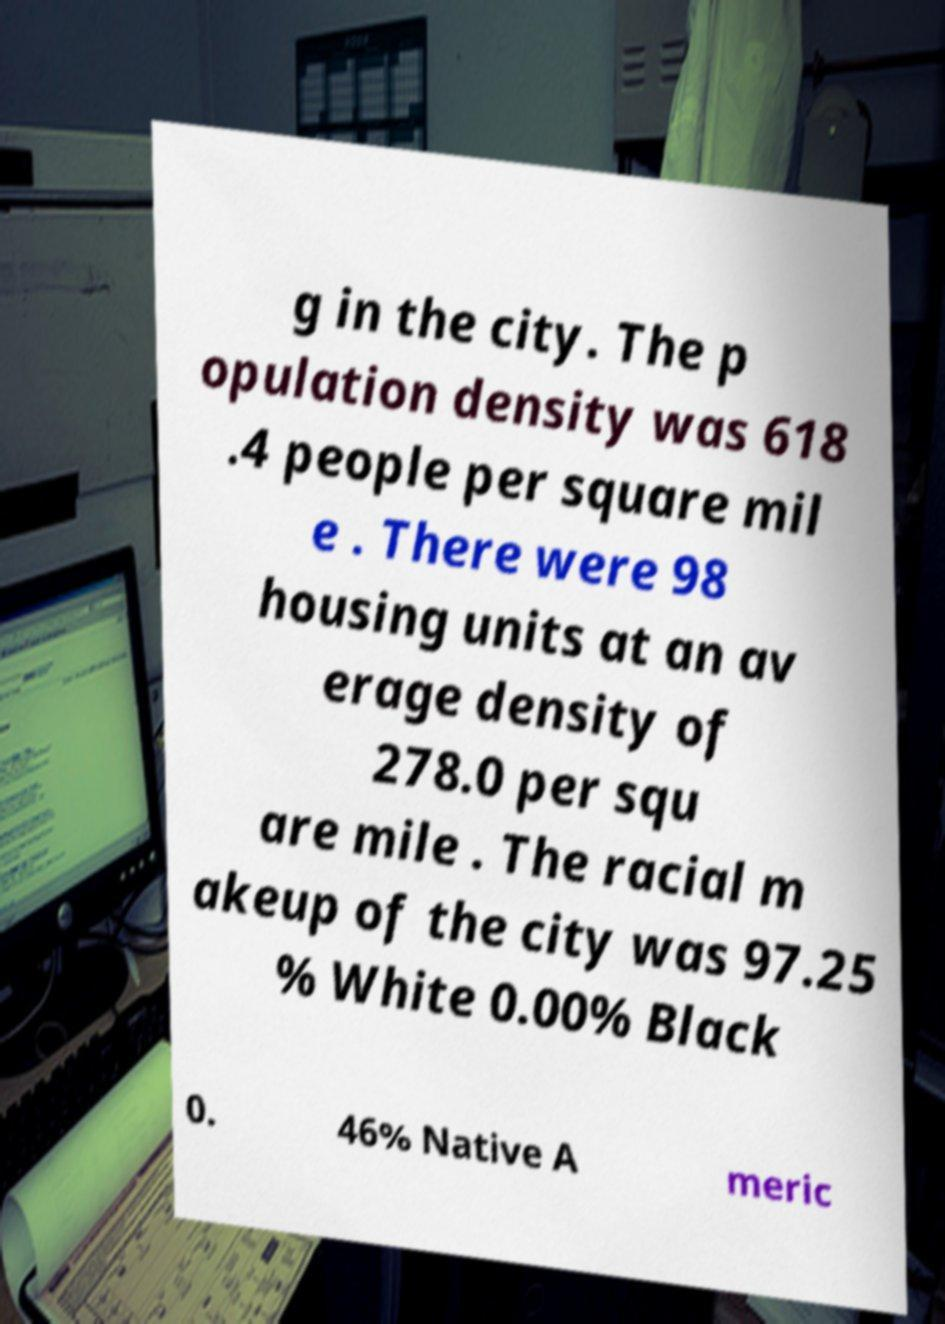I need the written content from this picture converted into text. Can you do that? g in the city. The p opulation density was 618 .4 people per square mil e . There were 98 housing units at an av erage density of 278.0 per squ are mile . The racial m akeup of the city was 97.25 % White 0.00% Black 0. 46% Native A meric 